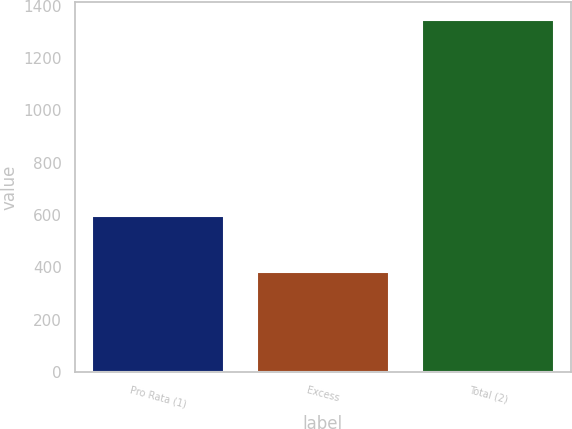<chart> <loc_0><loc_0><loc_500><loc_500><bar_chart><fcel>Pro Rata (1)<fcel>Excess<fcel>Total (2)<nl><fcel>594.9<fcel>380.6<fcel>1346.8<nl></chart> 